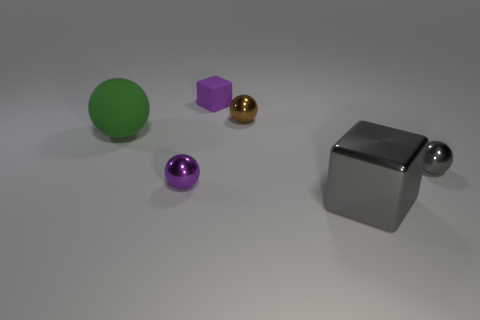How many objects are tiny metal spheres on the left side of the tiny brown shiny ball or purple shiny things?
Keep it short and to the point. 1. What color is the matte object that is the same shape as the brown metal thing?
Your response must be concise. Green. Does the tiny gray metal thing have the same shape as the small purple thing that is behind the brown ball?
Your response must be concise. No. What number of objects are either cubes that are behind the gray metal cube or small metallic objects left of the tiny gray sphere?
Your response must be concise. 3. Are there fewer large gray metallic cubes right of the big metallic object than tiny brown shiny blocks?
Provide a short and direct response. No. Is the tiny purple sphere made of the same material as the cube in front of the tiny purple cube?
Offer a terse response. Yes. What material is the gray sphere?
Ensure brevity in your answer.  Metal. What material is the small thing behind the tiny metal ball that is behind the big thing that is to the left of the tiny block made of?
Your answer should be compact. Rubber. There is a big cube; is its color the same as the shiny sphere that is left of the brown thing?
Give a very brief answer. No. Is there any other thing that is the same shape as the large metallic object?
Keep it short and to the point. Yes. 